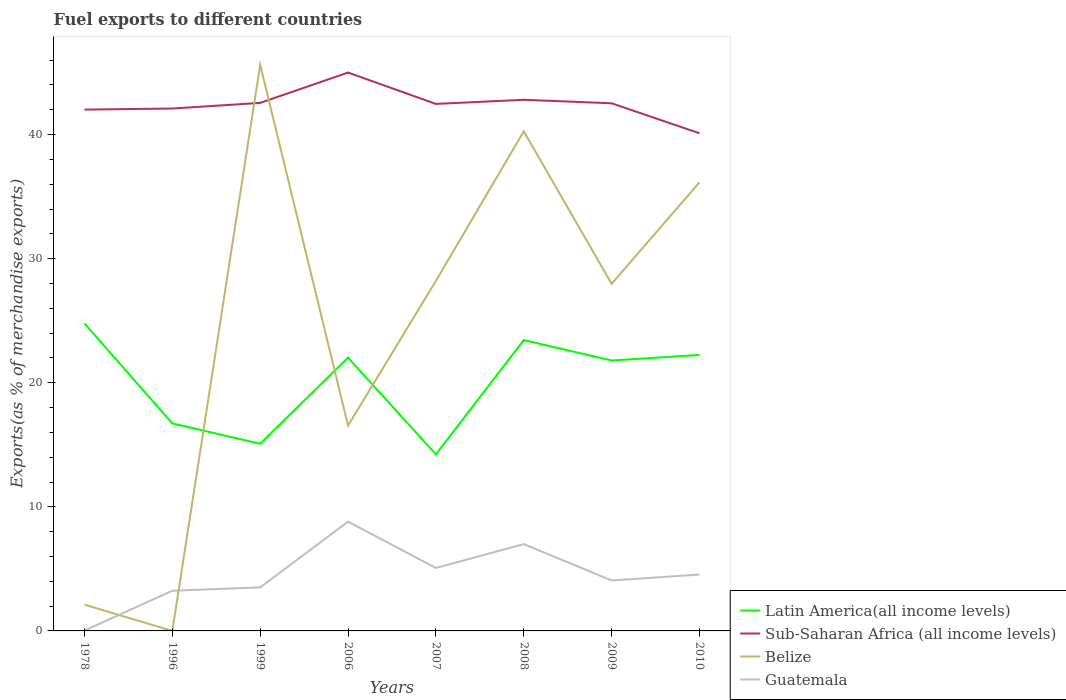Does the line corresponding to Latin America(all income levels) intersect with the line corresponding to Belize?
Your response must be concise. Yes. Is the number of lines equal to the number of legend labels?
Make the answer very short. Yes. Across all years, what is the maximum percentage of exports to different countries in Guatemala?
Your response must be concise. 0.03. What is the total percentage of exports to different countries in Latin America(all income levels) in the graph?
Keep it short and to the point. 9.69. What is the difference between the highest and the second highest percentage of exports to different countries in Belize?
Give a very brief answer. 45.62. What is the difference between the highest and the lowest percentage of exports to different countries in Latin America(all income levels)?
Offer a very short reply. 5. How many lines are there?
Give a very brief answer. 4. How many years are there in the graph?
Your response must be concise. 8. What is the difference between two consecutive major ticks on the Y-axis?
Provide a succinct answer. 10. Are the values on the major ticks of Y-axis written in scientific E-notation?
Your answer should be very brief. No. Does the graph contain grids?
Give a very brief answer. No. What is the title of the graph?
Provide a short and direct response. Fuel exports to different countries. Does "Other small states" appear as one of the legend labels in the graph?
Offer a very short reply. No. What is the label or title of the X-axis?
Your response must be concise. Years. What is the label or title of the Y-axis?
Your answer should be compact. Exports(as % of merchandise exports). What is the Exports(as % of merchandise exports) in Latin America(all income levels) in 1978?
Make the answer very short. 24.78. What is the Exports(as % of merchandise exports) of Sub-Saharan Africa (all income levels) in 1978?
Keep it short and to the point. 42.01. What is the Exports(as % of merchandise exports) in Belize in 1978?
Keep it short and to the point. 2.12. What is the Exports(as % of merchandise exports) of Guatemala in 1978?
Give a very brief answer. 0.03. What is the Exports(as % of merchandise exports) of Latin America(all income levels) in 1996?
Keep it short and to the point. 16.72. What is the Exports(as % of merchandise exports) of Sub-Saharan Africa (all income levels) in 1996?
Offer a terse response. 42.1. What is the Exports(as % of merchandise exports) of Belize in 1996?
Offer a terse response. 0. What is the Exports(as % of merchandise exports) in Guatemala in 1996?
Offer a terse response. 3.24. What is the Exports(as % of merchandise exports) of Latin America(all income levels) in 1999?
Give a very brief answer. 15.09. What is the Exports(as % of merchandise exports) of Sub-Saharan Africa (all income levels) in 1999?
Give a very brief answer. 42.55. What is the Exports(as % of merchandise exports) of Belize in 1999?
Make the answer very short. 45.62. What is the Exports(as % of merchandise exports) of Guatemala in 1999?
Keep it short and to the point. 3.51. What is the Exports(as % of merchandise exports) in Latin America(all income levels) in 2006?
Your response must be concise. 22.02. What is the Exports(as % of merchandise exports) in Sub-Saharan Africa (all income levels) in 2006?
Offer a terse response. 45. What is the Exports(as % of merchandise exports) in Belize in 2006?
Provide a succinct answer. 16.55. What is the Exports(as % of merchandise exports) of Guatemala in 2006?
Offer a terse response. 8.81. What is the Exports(as % of merchandise exports) in Latin America(all income levels) in 2007?
Your answer should be compact. 14.23. What is the Exports(as % of merchandise exports) of Sub-Saharan Africa (all income levels) in 2007?
Offer a terse response. 42.47. What is the Exports(as % of merchandise exports) in Belize in 2007?
Your response must be concise. 28.21. What is the Exports(as % of merchandise exports) in Guatemala in 2007?
Provide a short and direct response. 5.07. What is the Exports(as % of merchandise exports) of Latin America(all income levels) in 2008?
Provide a succinct answer. 23.44. What is the Exports(as % of merchandise exports) of Sub-Saharan Africa (all income levels) in 2008?
Make the answer very short. 42.8. What is the Exports(as % of merchandise exports) in Belize in 2008?
Your response must be concise. 40.26. What is the Exports(as % of merchandise exports) of Guatemala in 2008?
Offer a very short reply. 7. What is the Exports(as % of merchandise exports) of Latin America(all income levels) in 2009?
Ensure brevity in your answer.  21.79. What is the Exports(as % of merchandise exports) of Sub-Saharan Africa (all income levels) in 2009?
Provide a succinct answer. 42.52. What is the Exports(as % of merchandise exports) of Belize in 2009?
Your answer should be compact. 27.97. What is the Exports(as % of merchandise exports) in Guatemala in 2009?
Your response must be concise. 4.07. What is the Exports(as % of merchandise exports) of Latin America(all income levels) in 2010?
Keep it short and to the point. 22.24. What is the Exports(as % of merchandise exports) of Sub-Saharan Africa (all income levels) in 2010?
Provide a succinct answer. 40.1. What is the Exports(as % of merchandise exports) in Belize in 2010?
Make the answer very short. 36.15. What is the Exports(as % of merchandise exports) of Guatemala in 2010?
Provide a succinct answer. 4.54. Across all years, what is the maximum Exports(as % of merchandise exports) of Latin America(all income levels)?
Make the answer very short. 24.78. Across all years, what is the maximum Exports(as % of merchandise exports) in Sub-Saharan Africa (all income levels)?
Keep it short and to the point. 45. Across all years, what is the maximum Exports(as % of merchandise exports) in Belize?
Provide a short and direct response. 45.62. Across all years, what is the maximum Exports(as % of merchandise exports) of Guatemala?
Your response must be concise. 8.81. Across all years, what is the minimum Exports(as % of merchandise exports) in Latin America(all income levels)?
Provide a short and direct response. 14.23. Across all years, what is the minimum Exports(as % of merchandise exports) of Sub-Saharan Africa (all income levels)?
Keep it short and to the point. 40.1. Across all years, what is the minimum Exports(as % of merchandise exports) of Belize?
Provide a short and direct response. 0. Across all years, what is the minimum Exports(as % of merchandise exports) of Guatemala?
Make the answer very short. 0.03. What is the total Exports(as % of merchandise exports) in Latin America(all income levels) in the graph?
Make the answer very short. 160.31. What is the total Exports(as % of merchandise exports) of Sub-Saharan Africa (all income levels) in the graph?
Give a very brief answer. 339.56. What is the total Exports(as % of merchandise exports) in Belize in the graph?
Your response must be concise. 196.88. What is the total Exports(as % of merchandise exports) in Guatemala in the graph?
Your answer should be compact. 36.26. What is the difference between the Exports(as % of merchandise exports) of Latin America(all income levels) in 1978 and that in 1996?
Ensure brevity in your answer.  8.06. What is the difference between the Exports(as % of merchandise exports) of Sub-Saharan Africa (all income levels) in 1978 and that in 1996?
Ensure brevity in your answer.  -0.09. What is the difference between the Exports(as % of merchandise exports) in Belize in 1978 and that in 1996?
Keep it short and to the point. 2.12. What is the difference between the Exports(as % of merchandise exports) of Guatemala in 1978 and that in 1996?
Offer a very short reply. -3.21. What is the difference between the Exports(as % of merchandise exports) in Latin America(all income levels) in 1978 and that in 1999?
Your response must be concise. 9.69. What is the difference between the Exports(as % of merchandise exports) of Sub-Saharan Africa (all income levels) in 1978 and that in 1999?
Your answer should be very brief. -0.54. What is the difference between the Exports(as % of merchandise exports) in Belize in 1978 and that in 1999?
Keep it short and to the point. -43.5. What is the difference between the Exports(as % of merchandise exports) of Guatemala in 1978 and that in 1999?
Provide a succinct answer. -3.48. What is the difference between the Exports(as % of merchandise exports) in Latin America(all income levels) in 1978 and that in 2006?
Offer a very short reply. 2.76. What is the difference between the Exports(as % of merchandise exports) in Sub-Saharan Africa (all income levels) in 1978 and that in 2006?
Provide a short and direct response. -2.99. What is the difference between the Exports(as % of merchandise exports) of Belize in 1978 and that in 2006?
Your answer should be compact. -14.43. What is the difference between the Exports(as % of merchandise exports) in Guatemala in 1978 and that in 2006?
Offer a very short reply. -8.78. What is the difference between the Exports(as % of merchandise exports) in Latin America(all income levels) in 1978 and that in 2007?
Offer a very short reply. 10.55. What is the difference between the Exports(as % of merchandise exports) of Sub-Saharan Africa (all income levels) in 1978 and that in 2007?
Keep it short and to the point. -0.46. What is the difference between the Exports(as % of merchandise exports) in Belize in 1978 and that in 2007?
Give a very brief answer. -26.09. What is the difference between the Exports(as % of merchandise exports) of Guatemala in 1978 and that in 2007?
Offer a very short reply. -5.04. What is the difference between the Exports(as % of merchandise exports) of Latin America(all income levels) in 1978 and that in 2008?
Provide a succinct answer. 1.34. What is the difference between the Exports(as % of merchandise exports) in Sub-Saharan Africa (all income levels) in 1978 and that in 2008?
Give a very brief answer. -0.79. What is the difference between the Exports(as % of merchandise exports) in Belize in 1978 and that in 2008?
Keep it short and to the point. -38.15. What is the difference between the Exports(as % of merchandise exports) in Guatemala in 1978 and that in 2008?
Ensure brevity in your answer.  -6.97. What is the difference between the Exports(as % of merchandise exports) of Latin America(all income levels) in 1978 and that in 2009?
Provide a short and direct response. 2.99. What is the difference between the Exports(as % of merchandise exports) in Sub-Saharan Africa (all income levels) in 1978 and that in 2009?
Make the answer very short. -0.51. What is the difference between the Exports(as % of merchandise exports) in Belize in 1978 and that in 2009?
Make the answer very short. -25.86. What is the difference between the Exports(as % of merchandise exports) in Guatemala in 1978 and that in 2009?
Keep it short and to the point. -4.04. What is the difference between the Exports(as % of merchandise exports) in Latin America(all income levels) in 1978 and that in 2010?
Provide a short and direct response. 2.54. What is the difference between the Exports(as % of merchandise exports) of Sub-Saharan Africa (all income levels) in 1978 and that in 2010?
Ensure brevity in your answer.  1.91. What is the difference between the Exports(as % of merchandise exports) in Belize in 1978 and that in 2010?
Offer a terse response. -34.04. What is the difference between the Exports(as % of merchandise exports) of Guatemala in 1978 and that in 2010?
Your answer should be very brief. -4.51. What is the difference between the Exports(as % of merchandise exports) in Latin America(all income levels) in 1996 and that in 1999?
Your answer should be compact. 1.64. What is the difference between the Exports(as % of merchandise exports) in Sub-Saharan Africa (all income levels) in 1996 and that in 1999?
Provide a short and direct response. -0.45. What is the difference between the Exports(as % of merchandise exports) in Belize in 1996 and that in 1999?
Provide a short and direct response. -45.62. What is the difference between the Exports(as % of merchandise exports) of Guatemala in 1996 and that in 1999?
Offer a terse response. -0.27. What is the difference between the Exports(as % of merchandise exports) in Latin America(all income levels) in 1996 and that in 2006?
Offer a very short reply. -5.3. What is the difference between the Exports(as % of merchandise exports) in Sub-Saharan Africa (all income levels) in 1996 and that in 2006?
Offer a very short reply. -2.9. What is the difference between the Exports(as % of merchandise exports) in Belize in 1996 and that in 2006?
Offer a very short reply. -16.55. What is the difference between the Exports(as % of merchandise exports) in Guatemala in 1996 and that in 2006?
Give a very brief answer. -5.57. What is the difference between the Exports(as % of merchandise exports) of Latin America(all income levels) in 1996 and that in 2007?
Offer a terse response. 2.49. What is the difference between the Exports(as % of merchandise exports) of Sub-Saharan Africa (all income levels) in 1996 and that in 2007?
Provide a short and direct response. -0.37. What is the difference between the Exports(as % of merchandise exports) of Belize in 1996 and that in 2007?
Keep it short and to the point. -28.21. What is the difference between the Exports(as % of merchandise exports) of Guatemala in 1996 and that in 2007?
Offer a very short reply. -1.83. What is the difference between the Exports(as % of merchandise exports) of Latin America(all income levels) in 1996 and that in 2008?
Offer a very short reply. -6.71. What is the difference between the Exports(as % of merchandise exports) of Sub-Saharan Africa (all income levels) in 1996 and that in 2008?
Give a very brief answer. -0.7. What is the difference between the Exports(as % of merchandise exports) in Belize in 1996 and that in 2008?
Give a very brief answer. -40.26. What is the difference between the Exports(as % of merchandise exports) of Guatemala in 1996 and that in 2008?
Make the answer very short. -3.76. What is the difference between the Exports(as % of merchandise exports) of Latin America(all income levels) in 1996 and that in 2009?
Keep it short and to the point. -5.07. What is the difference between the Exports(as % of merchandise exports) of Sub-Saharan Africa (all income levels) in 1996 and that in 2009?
Give a very brief answer. -0.42. What is the difference between the Exports(as % of merchandise exports) in Belize in 1996 and that in 2009?
Offer a very short reply. -27.97. What is the difference between the Exports(as % of merchandise exports) of Guatemala in 1996 and that in 2009?
Ensure brevity in your answer.  -0.83. What is the difference between the Exports(as % of merchandise exports) in Latin America(all income levels) in 1996 and that in 2010?
Keep it short and to the point. -5.52. What is the difference between the Exports(as % of merchandise exports) of Sub-Saharan Africa (all income levels) in 1996 and that in 2010?
Provide a short and direct response. 2. What is the difference between the Exports(as % of merchandise exports) in Belize in 1996 and that in 2010?
Offer a terse response. -36.15. What is the difference between the Exports(as % of merchandise exports) in Guatemala in 1996 and that in 2010?
Provide a succinct answer. -1.31. What is the difference between the Exports(as % of merchandise exports) in Latin America(all income levels) in 1999 and that in 2006?
Your answer should be very brief. -6.93. What is the difference between the Exports(as % of merchandise exports) in Sub-Saharan Africa (all income levels) in 1999 and that in 2006?
Offer a very short reply. -2.45. What is the difference between the Exports(as % of merchandise exports) of Belize in 1999 and that in 2006?
Make the answer very short. 29.07. What is the difference between the Exports(as % of merchandise exports) of Guatemala in 1999 and that in 2006?
Your answer should be compact. -5.3. What is the difference between the Exports(as % of merchandise exports) of Latin America(all income levels) in 1999 and that in 2007?
Give a very brief answer. 0.86. What is the difference between the Exports(as % of merchandise exports) of Sub-Saharan Africa (all income levels) in 1999 and that in 2007?
Give a very brief answer. 0.08. What is the difference between the Exports(as % of merchandise exports) in Belize in 1999 and that in 2007?
Keep it short and to the point. 17.41. What is the difference between the Exports(as % of merchandise exports) in Guatemala in 1999 and that in 2007?
Provide a short and direct response. -1.57. What is the difference between the Exports(as % of merchandise exports) in Latin America(all income levels) in 1999 and that in 2008?
Your response must be concise. -8.35. What is the difference between the Exports(as % of merchandise exports) in Sub-Saharan Africa (all income levels) in 1999 and that in 2008?
Your answer should be very brief. -0.25. What is the difference between the Exports(as % of merchandise exports) of Belize in 1999 and that in 2008?
Keep it short and to the point. 5.35. What is the difference between the Exports(as % of merchandise exports) of Guatemala in 1999 and that in 2008?
Your answer should be compact. -3.49. What is the difference between the Exports(as % of merchandise exports) of Latin America(all income levels) in 1999 and that in 2009?
Keep it short and to the point. -6.71. What is the difference between the Exports(as % of merchandise exports) of Sub-Saharan Africa (all income levels) in 1999 and that in 2009?
Provide a short and direct response. 0.03. What is the difference between the Exports(as % of merchandise exports) in Belize in 1999 and that in 2009?
Ensure brevity in your answer.  17.64. What is the difference between the Exports(as % of merchandise exports) in Guatemala in 1999 and that in 2009?
Give a very brief answer. -0.56. What is the difference between the Exports(as % of merchandise exports) in Latin America(all income levels) in 1999 and that in 2010?
Keep it short and to the point. -7.16. What is the difference between the Exports(as % of merchandise exports) in Sub-Saharan Africa (all income levels) in 1999 and that in 2010?
Make the answer very short. 2.45. What is the difference between the Exports(as % of merchandise exports) of Belize in 1999 and that in 2010?
Provide a succinct answer. 9.46. What is the difference between the Exports(as % of merchandise exports) in Guatemala in 1999 and that in 2010?
Offer a very short reply. -1.04. What is the difference between the Exports(as % of merchandise exports) of Latin America(all income levels) in 2006 and that in 2007?
Make the answer very short. 7.79. What is the difference between the Exports(as % of merchandise exports) of Sub-Saharan Africa (all income levels) in 2006 and that in 2007?
Give a very brief answer. 2.53. What is the difference between the Exports(as % of merchandise exports) of Belize in 2006 and that in 2007?
Provide a succinct answer. -11.66. What is the difference between the Exports(as % of merchandise exports) of Guatemala in 2006 and that in 2007?
Offer a very short reply. 3.73. What is the difference between the Exports(as % of merchandise exports) of Latin America(all income levels) in 2006 and that in 2008?
Your answer should be compact. -1.42. What is the difference between the Exports(as % of merchandise exports) in Sub-Saharan Africa (all income levels) in 2006 and that in 2008?
Offer a very short reply. 2.19. What is the difference between the Exports(as % of merchandise exports) of Belize in 2006 and that in 2008?
Your response must be concise. -23.71. What is the difference between the Exports(as % of merchandise exports) in Guatemala in 2006 and that in 2008?
Provide a short and direct response. 1.81. What is the difference between the Exports(as % of merchandise exports) of Latin America(all income levels) in 2006 and that in 2009?
Provide a succinct answer. 0.23. What is the difference between the Exports(as % of merchandise exports) in Sub-Saharan Africa (all income levels) in 2006 and that in 2009?
Provide a short and direct response. 2.48. What is the difference between the Exports(as % of merchandise exports) of Belize in 2006 and that in 2009?
Your answer should be very brief. -11.42. What is the difference between the Exports(as % of merchandise exports) of Guatemala in 2006 and that in 2009?
Keep it short and to the point. 4.74. What is the difference between the Exports(as % of merchandise exports) in Latin America(all income levels) in 2006 and that in 2010?
Your answer should be very brief. -0.22. What is the difference between the Exports(as % of merchandise exports) of Sub-Saharan Africa (all income levels) in 2006 and that in 2010?
Provide a succinct answer. 4.89. What is the difference between the Exports(as % of merchandise exports) of Belize in 2006 and that in 2010?
Offer a very short reply. -19.6. What is the difference between the Exports(as % of merchandise exports) of Guatemala in 2006 and that in 2010?
Your response must be concise. 4.26. What is the difference between the Exports(as % of merchandise exports) of Latin America(all income levels) in 2007 and that in 2008?
Offer a terse response. -9.21. What is the difference between the Exports(as % of merchandise exports) of Sub-Saharan Africa (all income levels) in 2007 and that in 2008?
Offer a terse response. -0.33. What is the difference between the Exports(as % of merchandise exports) in Belize in 2007 and that in 2008?
Your answer should be compact. -12.05. What is the difference between the Exports(as % of merchandise exports) in Guatemala in 2007 and that in 2008?
Give a very brief answer. -1.92. What is the difference between the Exports(as % of merchandise exports) in Latin America(all income levels) in 2007 and that in 2009?
Provide a short and direct response. -7.56. What is the difference between the Exports(as % of merchandise exports) in Sub-Saharan Africa (all income levels) in 2007 and that in 2009?
Your answer should be compact. -0.05. What is the difference between the Exports(as % of merchandise exports) of Belize in 2007 and that in 2009?
Give a very brief answer. 0.24. What is the difference between the Exports(as % of merchandise exports) of Guatemala in 2007 and that in 2009?
Your answer should be very brief. 1.01. What is the difference between the Exports(as % of merchandise exports) in Latin America(all income levels) in 2007 and that in 2010?
Offer a terse response. -8.01. What is the difference between the Exports(as % of merchandise exports) in Sub-Saharan Africa (all income levels) in 2007 and that in 2010?
Keep it short and to the point. 2.37. What is the difference between the Exports(as % of merchandise exports) of Belize in 2007 and that in 2010?
Provide a short and direct response. -7.94. What is the difference between the Exports(as % of merchandise exports) of Guatemala in 2007 and that in 2010?
Offer a very short reply. 0.53. What is the difference between the Exports(as % of merchandise exports) in Latin America(all income levels) in 2008 and that in 2009?
Offer a very short reply. 1.65. What is the difference between the Exports(as % of merchandise exports) of Sub-Saharan Africa (all income levels) in 2008 and that in 2009?
Your answer should be very brief. 0.28. What is the difference between the Exports(as % of merchandise exports) in Belize in 2008 and that in 2009?
Offer a very short reply. 12.29. What is the difference between the Exports(as % of merchandise exports) of Guatemala in 2008 and that in 2009?
Give a very brief answer. 2.93. What is the difference between the Exports(as % of merchandise exports) of Latin America(all income levels) in 2008 and that in 2010?
Give a very brief answer. 1.2. What is the difference between the Exports(as % of merchandise exports) in Sub-Saharan Africa (all income levels) in 2008 and that in 2010?
Give a very brief answer. 2.7. What is the difference between the Exports(as % of merchandise exports) of Belize in 2008 and that in 2010?
Keep it short and to the point. 4.11. What is the difference between the Exports(as % of merchandise exports) of Guatemala in 2008 and that in 2010?
Make the answer very short. 2.45. What is the difference between the Exports(as % of merchandise exports) of Latin America(all income levels) in 2009 and that in 2010?
Make the answer very short. -0.45. What is the difference between the Exports(as % of merchandise exports) of Sub-Saharan Africa (all income levels) in 2009 and that in 2010?
Provide a short and direct response. 2.42. What is the difference between the Exports(as % of merchandise exports) in Belize in 2009 and that in 2010?
Provide a short and direct response. -8.18. What is the difference between the Exports(as % of merchandise exports) of Guatemala in 2009 and that in 2010?
Your response must be concise. -0.48. What is the difference between the Exports(as % of merchandise exports) of Latin America(all income levels) in 1978 and the Exports(as % of merchandise exports) of Sub-Saharan Africa (all income levels) in 1996?
Your response must be concise. -17.32. What is the difference between the Exports(as % of merchandise exports) in Latin America(all income levels) in 1978 and the Exports(as % of merchandise exports) in Belize in 1996?
Offer a very short reply. 24.78. What is the difference between the Exports(as % of merchandise exports) of Latin America(all income levels) in 1978 and the Exports(as % of merchandise exports) of Guatemala in 1996?
Your response must be concise. 21.54. What is the difference between the Exports(as % of merchandise exports) of Sub-Saharan Africa (all income levels) in 1978 and the Exports(as % of merchandise exports) of Belize in 1996?
Offer a very short reply. 42.01. What is the difference between the Exports(as % of merchandise exports) in Sub-Saharan Africa (all income levels) in 1978 and the Exports(as % of merchandise exports) in Guatemala in 1996?
Ensure brevity in your answer.  38.77. What is the difference between the Exports(as % of merchandise exports) of Belize in 1978 and the Exports(as % of merchandise exports) of Guatemala in 1996?
Keep it short and to the point. -1.12. What is the difference between the Exports(as % of merchandise exports) in Latin America(all income levels) in 1978 and the Exports(as % of merchandise exports) in Sub-Saharan Africa (all income levels) in 1999?
Make the answer very short. -17.77. What is the difference between the Exports(as % of merchandise exports) in Latin America(all income levels) in 1978 and the Exports(as % of merchandise exports) in Belize in 1999?
Your response must be concise. -20.84. What is the difference between the Exports(as % of merchandise exports) of Latin America(all income levels) in 1978 and the Exports(as % of merchandise exports) of Guatemala in 1999?
Ensure brevity in your answer.  21.27. What is the difference between the Exports(as % of merchandise exports) in Sub-Saharan Africa (all income levels) in 1978 and the Exports(as % of merchandise exports) in Belize in 1999?
Keep it short and to the point. -3.6. What is the difference between the Exports(as % of merchandise exports) in Sub-Saharan Africa (all income levels) in 1978 and the Exports(as % of merchandise exports) in Guatemala in 1999?
Ensure brevity in your answer.  38.51. What is the difference between the Exports(as % of merchandise exports) in Belize in 1978 and the Exports(as % of merchandise exports) in Guatemala in 1999?
Your response must be concise. -1.39. What is the difference between the Exports(as % of merchandise exports) of Latin America(all income levels) in 1978 and the Exports(as % of merchandise exports) of Sub-Saharan Africa (all income levels) in 2006?
Offer a very short reply. -20.22. What is the difference between the Exports(as % of merchandise exports) of Latin America(all income levels) in 1978 and the Exports(as % of merchandise exports) of Belize in 2006?
Offer a very short reply. 8.23. What is the difference between the Exports(as % of merchandise exports) of Latin America(all income levels) in 1978 and the Exports(as % of merchandise exports) of Guatemala in 2006?
Give a very brief answer. 15.97. What is the difference between the Exports(as % of merchandise exports) in Sub-Saharan Africa (all income levels) in 1978 and the Exports(as % of merchandise exports) in Belize in 2006?
Your answer should be very brief. 25.46. What is the difference between the Exports(as % of merchandise exports) in Sub-Saharan Africa (all income levels) in 1978 and the Exports(as % of merchandise exports) in Guatemala in 2006?
Offer a terse response. 33.21. What is the difference between the Exports(as % of merchandise exports) of Belize in 1978 and the Exports(as % of merchandise exports) of Guatemala in 2006?
Keep it short and to the point. -6.69. What is the difference between the Exports(as % of merchandise exports) of Latin America(all income levels) in 1978 and the Exports(as % of merchandise exports) of Sub-Saharan Africa (all income levels) in 2007?
Your response must be concise. -17.69. What is the difference between the Exports(as % of merchandise exports) of Latin America(all income levels) in 1978 and the Exports(as % of merchandise exports) of Belize in 2007?
Your answer should be very brief. -3.43. What is the difference between the Exports(as % of merchandise exports) in Latin America(all income levels) in 1978 and the Exports(as % of merchandise exports) in Guatemala in 2007?
Your answer should be very brief. 19.71. What is the difference between the Exports(as % of merchandise exports) in Sub-Saharan Africa (all income levels) in 1978 and the Exports(as % of merchandise exports) in Belize in 2007?
Offer a terse response. 13.8. What is the difference between the Exports(as % of merchandise exports) of Sub-Saharan Africa (all income levels) in 1978 and the Exports(as % of merchandise exports) of Guatemala in 2007?
Provide a short and direct response. 36.94. What is the difference between the Exports(as % of merchandise exports) in Belize in 1978 and the Exports(as % of merchandise exports) in Guatemala in 2007?
Give a very brief answer. -2.96. What is the difference between the Exports(as % of merchandise exports) in Latin America(all income levels) in 1978 and the Exports(as % of merchandise exports) in Sub-Saharan Africa (all income levels) in 2008?
Make the answer very short. -18.02. What is the difference between the Exports(as % of merchandise exports) of Latin America(all income levels) in 1978 and the Exports(as % of merchandise exports) of Belize in 2008?
Offer a very short reply. -15.48. What is the difference between the Exports(as % of merchandise exports) of Latin America(all income levels) in 1978 and the Exports(as % of merchandise exports) of Guatemala in 2008?
Your response must be concise. 17.78. What is the difference between the Exports(as % of merchandise exports) of Sub-Saharan Africa (all income levels) in 1978 and the Exports(as % of merchandise exports) of Belize in 2008?
Make the answer very short. 1.75. What is the difference between the Exports(as % of merchandise exports) of Sub-Saharan Africa (all income levels) in 1978 and the Exports(as % of merchandise exports) of Guatemala in 2008?
Ensure brevity in your answer.  35.02. What is the difference between the Exports(as % of merchandise exports) of Belize in 1978 and the Exports(as % of merchandise exports) of Guatemala in 2008?
Provide a succinct answer. -4.88. What is the difference between the Exports(as % of merchandise exports) in Latin America(all income levels) in 1978 and the Exports(as % of merchandise exports) in Sub-Saharan Africa (all income levels) in 2009?
Provide a succinct answer. -17.74. What is the difference between the Exports(as % of merchandise exports) in Latin America(all income levels) in 1978 and the Exports(as % of merchandise exports) in Belize in 2009?
Offer a terse response. -3.19. What is the difference between the Exports(as % of merchandise exports) of Latin America(all income levels) in 1978 and the Exports(as % of merchandise exports) of Guatemala in 2009?
Your response must be concise. 20.71. What is the difference between the Exports(as % of merchandise exports) of Sub-Saharan Africa (all income levels) in 1978 and the Exports(as % of merchandise exports) of Belize in 2009?
Your answer should be very brief. 14.04. What is the difference between the Exports(as % of merchandise exports) of Sub-Saharan Africa (all income levels) in 1978 and the Exports(as % of merchandise exports) of Guatemala in 2009?
Provide a short and direct response. 37.95. What is the difference between the Exports(as % of merchandise exports) in Belize in 1978 and the Exports(as % of merchandise exports) in Guatemala in 2009?
Give a very brief answer. -1.95. What is the difference between the Exports(as % of merchandise exports) of Latin America(all income levels) in 1978 and the Exports(as % of merchandise exports) of Sub-Saharan Africa (all income levels) in 2010?
Your answer should be compact. -15.32. What is the difference between the Exports(as % of merchandise exports) in Latin America(all income levels) in 1978 and the Exports(as % of merchandise exports) in Belize in 2010?
Your answer should be very brief. -11.37. What is the difference between the Exports(as % of merchandise exports) in Latin America(all income levels) in 1978 and the Exports(as % of merchandise exports) in Guatemala in 2010?
Your response must be concise. 20.24. What is the difference between the Exports(as % of merchandise exports) in Sub-Saharan Africa (all income levels) in 1978 and the Exports(as % of merchandise exports) in Belize in 2010?
Make the answer very short. 5.86. What is the difference between the Exports(as % of merchandise exports) in Sub-Saharan Africa (all income levels) in 1978 and the Exports(as % of merchandise exports) in Guatemala in 2010?
Provide a short and direct response. 37.47. What is the difference between the Exports(as % of merchandise exports) of Belize in 1978 and the Exports(as % of merchandise exports) of Guatemala in 2010?
Ensure brevity in your answer.  -2.43. What is the difference between the Exports(as % of merchandise exports) of Latin America(all income levels) in 1996 and the Exports(as % of merchandise exports) of Sub-Saharan Africa (all income levels) in 1999?
Provide a succinct answer. -25.83. What is the difference between the Exports(as % of merchandise exports) in Latin America(all income levels) in 1996 and the Exports(as % of merchandise exports) in Belize in 1999?
Offer a terse response. -28.89. What is the difference between the Exports(as % of merchandise exports) in Latin America(all income levels) in 1996 and the Exports(as % of merchandise exports) in Guatemala in 1999?
Make the answer very short. 13.22. What is the difference between the Exports(as % of merchandise exports) in Sub-Saharan Africa (all income levels) in 1996 and the Exports(as % of merchandise exports) in Belize in 1999?
Provide a succinct answer. -3.52. What is the difference between the Exports(as % of merchandise exports) in Sub-Saharan Africa (all income levels) in 1996 and the Exports(as % of merchandise exports) in Guatemala in 1999?
Ensure brevity in your answer.  38.59. What is the difference between the Exports(as % of merchandise exports) of Belize in 1996 and the Exports(as % of merchandise exports) of Guatemala in 1999?
Ensure brevity in your answer.  -3.51. What is the difference between the Exports(as % of merchandise exports) in Latin America(all income levels) in 1996 and the Exports(as % of merchandise exports) in Sub-Saharan Africa (all income levels) in 2006?
Offer a very short reply. -28.27. What is the difference between the Exports(as % of merchandise exports) in Latin America(all income levels) in 1996 and the Exports(as % of merchandise exports) in Belize in 2006?
Give a very brief answer. 0.18. What is the difference between the Exports(as % of merchandise exports) of Latin America(all income levels) in 1996 and the Exports(as % of merchandise exports) of Guatemala in 2006?
Keep it short and to the point. 7.92. What is the difference between the Exports(as % of merchandise exports) of Sub-Saharan Africa (all income levels) in 1996 and the Exports(as % of merchandise exports) of Belize in 2006?
Your answer should be very brief. 25.55. What is the difference between the Exports(as % of merchandise exports) in Sub-Saharan Africa (all income levels) in 1996 and the Exports(as % of merchandise exports) in Guatemala in 2006?
Give a very brief answer. 33.29. What is the difference between the Exports(as % of merchandise exports) of Belize in 1996 and the Exports(as % of merchandise exports) of Guatemala in 2006?
Your response must be concise. -8.81. What is the difference between the Exports(as % of merchandise exports) of Latin America(all income levels) in 1996 and the Exports(as % of merchandise exports) of Sub-Saharan Africa (all income levels) in 2007?
Ensure brevity in your answer.  -25.75. What is the difference between the Exports(as % of merchandise exports) in Latin America(all income levels) in 1996 and the Exports(as % of merchandise exports) in Belize in 2007?
Make the answer very short. -11.48. What is the difference between the Exports(as % of merchandise exports) of Latin America(all income levels) in 1996 and the Exports(as % of merchandise exports) of Guatemala in 2007?
Ensure brevity in your answer.  11.65. What is the difference between the Exports(as % of merchandise exports) of Sub-Saharan Africa (all income levels) in 1996 and the Exports(as % of merchandise exports) of Belize in 2007?
Provide a short and direct response. 13.89. What is the difference between the Exports(as % of merchandise exports) of Sub-Saharan Africa (all income levels) in 1996 and the Exports(as % of merchandise exports) of Guatemala in 2007?
Keep it short and to the point. 37.03. What is the difference between the Exports(as % of merchandise exports) in Belize in 1996 and the Exports(as % of merchandise exports) in Guatemala in 2007?
Your answer should be very brief. -5.07. What is the difference between the Exports(as % of merchandise exports) of Latin America(all income levels) in 1996 and the Exports(as % of merchandise exports) of Sub-Saharan Africa (all income levels) in 2008?
Your answer should be very brief. -26.08. What is the difference between the Exports(as % of merchandise exports) of Latin America(all income levels) in 1996 and the Exports(as % of merchandise exports) of Belize in 2008?
Make the answer very short. -23.54. What is the difference between the Exports(as % of merchandise exports) of Latin America(all income levels) in 1996 and the Exports(as % of merchandise exports) of Guatemala in 2008?
Provide a short and direct response. 9.73. What is the difference between the Exports(as % of merchandise exports) in Sub-Saharan Africa (all income levels) in 1996 and the Exports(as % of merchandise exports) in Belize in 2008?
Your response must be concise. 1.84. What is the difference between the Exports(as % of merchandise exports) of Sub-Saharan Africa (all income levels) in 1996 and the Exports(as % of merchandise exports) of Guatemala in 2008?
Give a very brief answer. 35.1. What is the difference between the Exports(as % of merchandise exports) of Belize in 1996 and the Exports(as % of merchandise exports) of Guatemala in 2008?
Make the answer very short. -7. What is the difference between the Exports(as % of merchandise exports) of Latin America(all income levels) in 1996 and the Exports(as % of merchandise exports) of Sub-Saharan Africa (all income levels) in 2009?
Your answer should be very brief. -25.8. What is the difference between the Exports(as % of merchandise exports) in Latin America(all income levels) in 1996 and the Exports(as % of merchandise exports) in Belize in 2009?
Give a very brief answer. -11.25. What is the difference between the Exports(as % of merchandise exports) of Latin America(all income levels) in 1996 and the Exports(as % of merchandise exports) of Guatemala in 2009?
Offer a very short reply. 12.66. What is the difference between the Exports(as % of merchandise exports) in Sub-Saharan Africa (all income levels) in 1996 and the Exports(as % of merchandise exports) in Belize in 2009?
Provide a short and direct response. 14.13. What is the difference between the Exports(as % of merchandise exports) in Sub-Saharan Africa (all income levels) in 1996 and the Exports(as % of merchandise exports) in Guatemala in 2009?
Provide a short and direct response. 38.03. What is the difference between the Exports(as % of merchandise exports) of Belize in 1996 and the Exports(as % of merchandise exports) of Guatemala in 2009?
Your answer should be compact. -4.07. What is the difference between the Exports(as % of merchandise exports) of Latin America(all income levels) in 1996 and the Exports(as % of merchandise exports) of Sub-Saharan Africa (all income levels) in 2010?
Provide a succinct answer. -23.38. What is the difference between the Exports(as % of merchandise exports) of Latin America(all income levels) in 1996 and the Exports(as % of merchandise exports) of Belize in 2010?
Ensure brevity in your answer.  -19.43. What is the difference between the Exports(as % of merchandise exports) in Latin America(all income levels) in 1996 and the Exports(as % of merchandise exports) in Guatemala in 2010?
Provide a succinct answer. 12.18. What is the difference between the Exports(as % of merchandise exports) in Sub-Saharan Africa (all income levels) in 1996 and the Exports(as % of merchandise exports) in Belize in 2010?
Your answer should be compact. 5.95. What is the difference between the Exports(as % of merchandise exports) of Sub-Saharan Africa (all income levels) in 1996 and the Exports(as % of merchandise exports) of Guatemala in 2010?
Provide a short and direct response. 37.56. What is the difference between the Exports(as % of merchandise exports) of Belize in 1996 and the Exports(as % of merchandise exports) of Guatemala in 2010?
Keep it short and to the point. -4.54. What is the difference between the Exports(as % of merchandise exports) in Latin America(all income levels) in 1999 and the Exports(as % of merchandise exports) in Sub-Saharan Africa (all income levels) in 2006?
Your answer should be very brief. -29.91. What is the difference between the Exports(as % of merchandise exports) in Latin America(all income levels) in 1999 and the Exports(as % of merchandise exports) in Belize in 2006?
Your response must be concise. -1.46. What is the difference between the Exports(as % of merchandise exports) of Latin America(all income levels) in 1999 and the Exports(as % of merchandise exports) of Guatemala in 2006?
Provide a succinct answer. 6.28. What is the difference between the Exports(as % of merchandise exports) in Sub-Saharan Africa (all income levels) in 1999 and the Exports(as % of merchandise exports) in Belize in 2006?
Give a very brief answer. 26. What is the difference between the Exports(as % of merchandise exports) of Sub-Saharan Africa (all income levels) in 1999 and the Exports(as % of merchandise exports) of Guatemala in 2006?
Keep it short and to the point. 33.75. What is the difference between the Exports(as % of merchandise exports) in Belize in 1999 and the Exports(as % of merchandise exports) in Guatemala in 2006?
Offer a very short reply. 36.81. What is the difference between the Exports(as % of merchandise exports) in Latin America(all income levels) in 1999 and the Exports(as % of merchandise exports) in Sub-Saharan Africa (all income levels) in 2007?
Your answer should be very brief. -27.38. What is the difference between the Exports(as % of merchandise exports) of Latin America(all income levels) in 1999 and the Exports(as % of merchandise exports) of Belize in 2007?
Give a very brief answer. -13.12. What is the difference between the Exports(as % of merchandise exports) in Latin America(all income levels) in 1999 and the Exports(as % of merchandise exports) in Guatemala in 2007?
Provide a short and direct response. 10.01. What is the difference between the Exports(as % of merchandise exports) in Sub-Saharan Africa (all income levels) in 1999 and the Exports(as % of merchandise exports) in Belize in 2007?
Offer a terse response. 14.34. What is the difference between the Exports(as % of merchandise exports) of Sub-Saharan Africa (all income levels) in 1999 and the Exports(as % of merchandise exports) of Guatemala in 2007?
Offer a very short reply. 37.48. What is the difference between the Exports(as % of merchandise exports) of Belize in 1999 and the Exports(as % of merchandise exports) of Guatemala in 2007?
Your answer should be very brief. 40.54. What is the difference between the Exports(as % of merchandise exports) in Latin America(all income levels) in 1999 and the Exports(as % of merchandise exports) in Sub-Saharan Africa (all income levels) in 2008?
Your response must be concise. -27.72. What is the difference between the Exports(as % of merchandise exports) of Latin America(all income levels) in 1999 and the Exports(as % of merchandise exports) of Belize in 2008?
Keep it short and to the point. -25.18. What is the difference between the Exports(as % of merchandise exports) in Latin America(all income levels) in 1999 and the Exports(as % of merchandise exports) in Guatemala in 2008?
Offer a terse response. 8.09. What is the difference between the Exports(as % of merchandise exports) in Sub-Saharan Africa (all income levels) in 1999 and the Exports(as % of merchandise exports) in Belize in 2008?
Your answer should be very brief. 2.29. What is the difference between the Exports(as % of merchandise exports) of Sub-Saharan Africa (all income levels) in 1999 and the Exports(as % of merchandise exports) of Guatemala in 2008?
Ensure brevity in your answer.  35.56. What is the difference between the Exports(as % of merchandise exports) in Belize in 1999 and the Exports(as % of merchandise exports) in Guatemala in 2008?
Make the answer very short. 38.62. What is the difference between the Exports(as % of merchandise exports) of Latin America(all income levels) in 1999 and the Exports(as % of merchandise exports) of Sub-Saharan Africa (all income levels) in 2009?
Provide a short and direct response. -27.44. What is the difference between the Exports(as % of merchandise exports) in Latin America(all income levels) in 1999 and the Exports(as % of merchandise exports) in Belize in 2009?
Ensure brevity in your answer.  -12.89. What is the difference between the Exports(as % of merchandise exports) of Latin America(all income levels) in 1999 and the Exports(as % of merchandise exports) of Guatemala in 2009?
Offer a very short reply. 11.02. What is the difference between the Exports(as % of merchandise exports) in Sub-Saharan Africa (all income levels) in 1999 and the Exports(as % of merchandise exports) in Belize in 2009?
Make the answer very short. 14.58. What is the difference between the Exports(as % of merchandise exports) in Sub-Saharan Africa (all income levels) in 1999 and the Exports(as % of merchandise exports) in Guatemala in 2009?
Your answer should be very brief. 38.49. What is the difference between the Exports(as % of merchandise exports) in Belize in 1999 and the Exports(as % of merchandise exports) in Guatemala in 2009?
Offer a terse response. 41.55. What is the difference between the Exports(as % of merchandise exports) in Latin America(all income levels) in 1999 and the Exports(as % of merchandise exports) in Sub-Saharan Africa (all income levels) in 2010?
Offer a terse response. -25.02. What is the difference between the Exports(as % of merchandise exports) in Latin America(all income levels) in 1999 and the Exports(as % of merchandise exports) in Belize in 2010?
Your answer should be compact. -21.07. What is the difference between the Exports(as % of merchandise exports) of Latin America(all income levels) in 1999 and the Exports(as % of merchandise exports) of Guatemala in 2010?
Offer a very short reply. 10.54. What is the difference between the Exports(as % of merchandise exports) of Sub-Saharan Africa (all income levels) in 1999 and the Exports(as % of merchandise exports) of Belize in 2010?
Offer a very short reply. 6.4. What is the difference between the Exports(as % of merchandise exports) of Sub-Saharan Africa (all income levels) in 1999 and the Exports(as % of merchandise exports) of Guatemala in 2010?
Your response must be concise. 38.01. What is the difference between the Exports(as % of merchandise exports) in Belize in 1999 and the Exports(as % of merchandise exports) in Guatemala in 2010?
Offer a very short reply. 41.07. What is the difference between the Exports(as % of merchandise exports) of Latin America(all income levels) in 2006 and the Exports(as % of merchandise exports) of Sub-Saharan Africa (all income levels) in 2007?
Offer a terse response. -20.45. What is the difference between the Exports(as % of merchandise exports) of Latin America(all income levels) in 2006 and the Exports(as % of merchandise exports) of Belize in 2007?
Your answer should be compact. -6.19. What is the difference between the Exports(as % of merchandise exports) in Latin America(all income levels) in 2006 and the Exports(as % of merchandise exports) in Guatemala in 2007?
Your response must be concise. 16.95. What is the difference between the Exports(as % of merchandise exports) of Sub-Saharan Africa (all income levels) in 2006 and the Exports(as % of merchandise exports) of Belize in 2007?
Ensure brevity in your answer.  16.79. What is the difference between the Exports(as % of merchandise exports) in Sub-Saharan Africa (all income levels) in 2006 and the Exports(as % of merchandise exports) in Guatemala in 2007?
Provide a short and direct response. 39.93. What is the difference between the Exports(as % of merchandise exports) of Belize in 2006 and the Exports(as % of merchandise exports) of Guatemala in 2007?
Provide a succinct answer. 11.47. What is the difference between the Exports(as % of merchandise exports) of Latin America(all income levels) in 2006 and the Exports(as % of merchandise exports) of Sub-Saharan Africa (all income levels) in 2008?
Provide a succinct answer. -20.79. What is the difference between the Exports(as % of merchandise exports) in Latin America(all income levels) in 2006 and the Exports(as % of merchandise exports) in Belize in 2008?
Give a very brief answer. -18.24. What is the difference between the Exports(as % of merchandise exports) in Latin America(all income levels) in 2006 and the Exports(as % of merchandise exports) in Guatemala in 2008?
Provide a succinct answer. 15.02. What is the difference between the Exports(as % of merchandise exports) of Sub-Saharan Africa (all income levels) in 2006 and the Exports(as % of merchandise exports) of Belize in 2008?
Ensure brevity in your answer.  4.74. What is the difference between the Exports(as % of merchandise exports) in Sub-Saharan Africa (all income levels) in 2006 and the Exports(as % of merchandise exports) in Guatemala in 2008?
Offer a terse response. 38. What is the difference between the Exports(as % of merchandise exports) of Belize in 2006 and the Exports(as % of merchandise exports) of Guatemala in 2008?
Your answer should be compact. 9.55. What is the difference between the Exports(as % of merchandise exports) of Latin America(all income levels) in 2006 and the Exports(as % of merchandise exports) of Sub-Saharan Africa (all income levels) in 2009?
Provide a succinct answer. -20.5. What is the difference between the Exports(as % of merchandise exports) in Latin America(all income levels) in 2006 and the Exports(as % of merchandise exports) in Belize in 2009?
Provide a succinct answer. -5.95. What is the difference between the Exports(as % of merchandise exports) of Latin America(all income levels) in 2006 and the Exports(as % of merchandise exports) of Guatemala in 2009?
Your answer should be compact. 17.95. What is the difference between the Exports(as % of merchandise exports) in Sub-Saharan Africa (all income levels) in 2006 and the Exports(as % of merchandise exports) in Belize in 2009?
Provide a short and direct response. 17.03. What is the difference between the Exports(as % of merchandise exports) of Sub-Saharan Africa (all income levels) in 2006 and the Exports(as % of merchandise exports) of Guatemala in 2009?
Keep it short and to the point. 40.93. What is the difference between the Exports(as % of merchandise exports) in Belize in 2006 and the Exports(as % of merchandise exports) in Guatemala in 2009?
Make the answer very short. 12.48. What is the difference between the Exports(as % of merchandise exports) in Latin America(all income levels) in 2006 and the Exports(as % of merchandise exports) in Sub-Saharan Africa (all income levels) in 2010?
Ensure brevity in your answer.  -18.09. What is the difference between the Exports(as % of merchandise exports) of Latin America(all income levels) in 2006 and the Exports(as % of merchandise exports) of Belize in 2010?
Offer a very short reply. -14.13. What is the difference between the Exports(as % of merchandise exports) of Latin America(all income levels) in 2006 and the Exports(as % of merchandise exports) of Guatemala in 2010?
Your answer should be compact. 17.47. What is the difference between the Exports(as % of merchandise exports) of Sub-Saharan Africa (all income levels) in 2006 and the Exports(as % of merchandise exports) of Belize in 2010?
Offer a very short reply. 8.85. What is the difference between the Exports(as % of merchandise exports) in Sub-Saharan Africa (all income levels) in 2006 and the Exports(as % of merchandise exports) in Guatemala in 2010?
Your response must be concise. 40.45. What is the difference between the Exports(as % of merchandise exports) of Belize in 2006 and the Exports(as % of merchandise exports) of Guatemala in 2010?
Offer a very short reply. 12. What is the difference between the Exports(as % of merchandise exports) in Latin America(all income levels) in 2007 and the Exports(as % of merchandise exports) in Sub-Saharan Africa (all income levels) in 2008?
Give a very brief answer. -28.57. What is the difference between the Exports(as % of merchandise exports) in Latin America(all income levels) in 2007 and the Exports(as % of merchandise exports) in Belize in 2008?
Your response must be concise. -26.03. What is the difference between the Exports(as % of merchandise exports) in Latin America(all income levels) in 2007 and the Exports(as % of merchandise exports) in Guatemala in 2008?
Ensure brevity in your answer.  7.23. What is the difference between the Exports(as % of merchandise exports) in Sub-Saharan Africa (all income levels) in 2007 and the Exports(as % of merchandise exports) in Belize in 2008?
Offer a very short reply. 2.21. What is the difference between the Exports(as % of merchandise exports) of Sub-Saharan Africa (all income levels) in 2007 and the Exports(as % of merchandise exports) of Guatemala in 2008?
Your response must be concise. 35.47. What is the difference between the Exports(as % of merchandise exports) of Belize in 2007 and the Exports(as % of merchandise exports) of Guatemala in 2008?
Offer a terse response. 21.21. What is the difference between the Exports(as % of merchandise exports) of Latin America(all income levels) in 2007 and the Exports(as % of merchandise exports) of Sub-Saharan Africa (all income levels) in 2009?
Make the answer very short. -28.29. What is the difference between the Exports(as % of merchandise exports) in Latin America(all income levels) in 2007 and the Exports(as % of merchandise exports) in Belize in 2009?
Offer a terse response. -13.74. What is the difference between the Exports(as % of merchandise exports) in Latin America(all income levels) in 2007 and the Exports(as % of merchandise exports) in Guatemala in 2009?
Your answer should be compact. 10.16. What is the difference between the Exports(as % of merchandise exports) of Sub-Saharan Africa (all income levels) in 2007 and the Exports(as % of merchandise exports) of Belize in 2009?
Offer a very short reply. 14.5. What is the difference between the Exports(as % of merchandise exports) of Sub-Saharan Africa (all income levels) in 2007 and the Exports(as % of merchandise exports) of Guatemala in 2009?
Offer a terse response. 38.4. What is the difference between the Exports(as % of merchandise exports) in Belize in 2007 and the Exports(as % of merchandise exports) in Guatemala in 2009?
Your answer should be very brief. 24.14. What is the difference between the Exports(as % of merchandise exports) of Latin America(all income levels) in 2007 and the Exports(as % of merchandise exports) of Sub-Saharan Africa (all income levels) in 2010?
Offer a very short reply. -25.88. What is the difference between the Exports(as % of merchandise exports) in Latin America(all income levels) in 2007 and the Exports(as % of merchandise exports) in Belize in 2010?
Provide a short and direct response. -21.92. What is the difference between the Exports(as % of merchandise exports) in Latin America(all income levels) in 2007 and the Exports(as % of merchandise exports) in Guatemala in 2010?
Your answer should be compact. 9.69. What is the difference between the Exports(as % of merchandise exports) of Sub-Saharan Africa (all income levels) in 2007 and the Exports(as % of merchandise exports) of Belize in 2010?
Provide a succinct answer. 6.32. What is the difference between the Exports(as % of merchandise exports) of Sub-Saharan Africa (all income levels) in 2007 and the Exports(as % of merchandise exports) of Guatemala in 2010?
Ensure brevity in your answer.  37.93. What is the difference between the Exports(as % of merchandise exports) in Belize in 2007 and the Exports(as % of merchandise exports) in Guatemala in 2010?
Offer a terse response. 23.66. What is the difference between the Exports(as % of merchandise exports) of Latin America(all income levels) in 2008 and the Exports(as % of merchandise exports) of Sub-Saharan Africa (all income levels) in 2009?
Your answer should be compact. -19.08. What is the difference between the Exports(as % of merchandise exports) in Latin America(all income levels) in 2008 and the Exports(as % of merchandise exports) in Belize in 2009?
Your answer should be compact. -4.53. What is the difference between the Exports(as % of merchandise exports) in Latin America(all income levels) in 2008 and the Exports(as % of merchandise exports) in Guatemala in 2009?
Provide a succinct answer. 19.37. What is the difference between the Exports(as % of merchandise exports) of Sub-Saharan Africa (all income levels) in 2008 and the Exports(as % of merchandise exports) of Belize in 2009?
Offer a very short reply. 14.83. What is the difference between the Exports(as % of merchandise exports) of Sub-Saharan Africa (all income levels) in 2008 and the Exports(as % of merchandise exports) of Guatemala in 2009?
Your answer should be very brief. 38.74. What is the difference between the Exports(as % of merchandise exports) in Belize in 2008 and the Exports(as % of merchandise exports) in Guatemala in 2009?
Ensure brevity in your answer.  36.2. What is the difference between the Exports(as % of merchandise exports) of Latin America(all income levels) in 2008 and the Exports(as % of merchandise exports) of Sub-Saharan Africa (all income levels) in 2010?
Offer a very short reply. -16.67. What is the difference between the Exports(as % of merchandise exports) of Latin America(all income levels) in 2008 and the Exports(as % of merchandise exports) of Belize in 2010?
Make the answer very short. -12.71. What is the difference between the Exports(as % of merchandise exports) in Latin America(all income levels) in 2008 and the Exports(as % of merchandise exports) in Guatemala in 2010?
Your answer should be compact. 18.89. What is the difference between the Exports(as % of merchandise exports) in Sub-Saharan Africa (all income levels) in 2008 and the Exports(as % of merchandise exports) in Belize in 2010?
Your response must be concise. 6.65. What is the difference between the Exports(as % of merchandise exports) of Sub-Saharan Africa (all income levels) in 2008 and the Exports(as % of merchandise exports) of Guatemala in 2010?
Keep it short and to the point. 38.26. What is the difference between the Exports(as % of merchandise exports) in Belize in 2008 and the Exports(as % of merchandise exports) in Guatemala in 2010?
Your answer should be very brief. 35.72. What is the difference between the Exports(as % of merchandise exports) of Latin America(all income levels) in 2009 and the Exports(as % of merchandise exports) of Sub-Saharan Africa (all income levels) in 2010?
Offer a very short reply. -18.31. What is the difference between the Exports(as % of merchandise exports) of Latin America(all income levels) in 2009 and the Exports(as % of merchandise exports) of Belize in 2010?
Give a very brief answer. -14.36. What is the difference between the Exports(as % of merchandise exports) of Latin America(all income levels) in 2009 and the Exports(as % of merchandise exports) of Guatemala in 2010?
Give a very brief answer. 17.25. What is the difference between the Exports(as % of merchandise exports) in Sub-Saharan Africa (all income levels) in 2009 and the Exports(as % of merchandise exports) in Belize in 2010?
Give a very brief answer. 6.37. What is the difference between the Exports(as % of merchandise exports) of Sub-Saharan Africa (all income levels) in 2009 and the Exports(as % of merchandise exports) of Guatemala in 2010?
Offer a very short reply. 37.98. What is the difference between the Exports(as % of merchandise exports) in Belize in 2009 and the Exports(as % of merchandise exports) in Guatemala in 2010?
Keep it short and to the point. 23.43. What is the average Exports(as % of merchandise exports) of Latin America(all income levels) per year?
Your response must be concise. 20.04. What is the average Exports(as % of merchandise exports) in Sub-Saharan Africa (all income levels) per year?
Your answer should be very brief. 42.45. What is the average Exports(as % of merchandise exports) of Belize per year?
Your answer should be very brief. 24.61. What is the average Exports(as % of merchandise exports) in Guatemala per year?
Keep it short and to the point. 4.53. In the year 1978, what is the difference between the Exports(as % of merchandise exports) of Latin America(all income levels) and Exports(as % of merchandise exports) of Sub-Saharan Africa (all income levels)?
Your answer should be very brief. -17.23. In the year 1978, what is the difference between the Exports(as % of merchandise exports) in Latin America(all income levels) and Exports(as % of merchandise exports) in Belize?
Your response must be concise. 22.66. In the year 1978, what is the difference between the Exports(as % of merchandise exports) in Latin America(all income levels) and Exports(as % of merchandise exports) in Guatemala?
Your response must be concise. 24.75. In the year 1978, what is the difference between the Exports(as % of merchandise exports) of Sub-Saharan Africa (all income levels) and Exports(as % of merchandise exports) of Belize?
Give a very brief answer. 39.9. In the year 1978, what is the difference between the Exports(as % of merchandise exports) in Sub-Saharan Africa (all income levels) and Exports(as % of merchandise exports) in Guatemala?
Offer a very short reply. 41.98. In the year 1978, what is the difference between the Exports(as % of merchandise exports) of Belize and Exports(as % of merchandise exports) of Guatemala?
Provide a succinct answer. 2.09. In the year 1996, what is the difference between the Exports(as % of merchandise exports) in Latin America(all income levels) and Exports(as % of merchandise exports) in Sub-Saharan Africa (all income levels)?
Offer a very short reply. -25.38. In the year 1996, what is the difference between the Exports(as % of merchandise exports) in Latin America(all income levels) and Exports(as % of merchandise exports) in Belize?
Your answer should be compact. 16.72. In the year 1996, what is the difference between the Exports(as % of merchandise exports) of Latin America(all income levels) and Exports(as % of merchandise exports) of Guatemala?
Your response must be concise. 13.48. In the year 1996, what is the difference between the Exports(as % of merchandise exports) of Sub-Saharan Africa (all income levels) and Exports(as % of merchandise exports) of Belize?
Make the answer very short. 42.1. In the year 1996, what is the difference between the Exports(as % of merchandise exports) in Sub-Saharan Africa (all income levels) and Exports(as % of merchandise exports) in Guatemala?
Provide a short and direct response. 38.86. In the year 1996, what is the difference between the Exports(as % of merchandise exports) of Belize and Exports(as % of merchandise exports) of Guatemala?
Offer a terse response. -3.24. In the year 1999, what is the difference between the Exports(as % of merchandise exports) in Latin America(all income levels) and Exports(as % of merchandise exports) in Sub-Saharan Africa (all income levels)?
Keep it short and to the point. -27.47. In the year 1999, what is the difference between the Exports(as % of merchandise exports) in Latin America(all income levels) and Exports(as % of merchandise exports) in Belize?
Provide a succinct answer. -30.53. In the year 1999, what is the difference between the Exports(as % of merchandise exports) of Latin America(all income levels) and Exports(as % of merchandise exports) of Guatemala?
Provide a succinct answer. 11.58. In the year 1999, what is the difference between the Exports(as % of merchandise exports) of Sub-Saharan Africa (all income levels) and Exports(as % of merchandise exports) of Belize?
Offer a very short reply. -3.06. In the year 1999, what is the difference between the Exports(as % of merchandise exports) of Sub-Saharan Africa (all income levels) and Exports(as % of merchandise exports) of Guatemala?
Provide a succinct answer. 39.05. In the year 1999, what is the difference between the Exports(as % of merchandise exports) in Belize and Exports(as % of merchandise exports) in Guatemala?
Your response must be concise. 42.11. In the year 2006, what is the difference between the Exports(as % of merchandise exports) in Latin America(all income levels) and Exports(as % of merchandise exports) in Sub-Saharan Africa (all income levels)?
Make the answer very short. -22.98. In the year 2006, what is the difference between the Exports(as % of merchandise exports) of Latin America(all income levels) and Exports(as % of merchandise exports) of Belize?
Your response must be concise. 5.47. In the year 2006, what is the difference between the Exports(as % of merchandise exports) in Latin America(all income levels) and Exports(as % of merchandise exports) in Guatemala?
Ensure brevity in your answer.  13.21. In the year 2006, what is the difference between the Exports(as % of merchandise exports) in Sub-Saharan Africa (all income levels) and Exports(as % of merchandise exports) in Belize?
Your answer should be very brief. 28.45. In the year 2006, what is the difference between the Exports(as % of merchandise exports) in Sub-Saharan Africa (all income levels) and Exports(as % of merchandise exports) in Guatemala?
Provide a succinct answer. 36.19. In the year 2006, what is the difference between the Exports(as % of merchandise exports) of Belize and Exports(as % of merchandise exports) of Guatemala?
Your response must be concise. 7.74. In the year 2007, what is the difference between the Exports(as % of merchandise exports) in Latin America(all income levels) and Exports(as % of merchandise exports) in Sub-Saharan Africa (all income levels)?
Make the answer very short. -28.24. In the year 2007, what is the difference between the Exports(as % of merchandise exports) of Latin America(all income levels) and Exports(as % of merchandise exports) of Belize?
Ensure brevity in your answer.  -13.98. In the year 2007, what is the difference between the Exports(as % of merchandise exports) in Latin America(all income levels) and Exports(as % of merchandise exports) in Guatemala?
Your answer should be compact. 9.16. In the year 2007, what is the difference between the Exports(as % of merchandise exports) of Sub-Saharan Africa (all income levels) and Exports(as % of merchandise exports) of Belize?
Ensure brevity in your answer.  14.26. In the year 2007, what is the difference between the Exports(as % of merchandise exports) of Sub-Saharan Africa (all income levels) and Exports(as % of merchandise exports) of Guatemala?
Your answer should be very brief. 37.4. In the year 2007, what is the difference between the Exports(as % of merchandise exports) in Belize and Exports(as % of merchandise exports) in Guatemala?
Ensure brevity in your answer.  23.13. In the year 2008, what is the difference between the Exports(as % of merchandise exports) of Latin America(all income levels) and Exports(as % of merchandise exports) of Sub-Saharan Africa (all income levels)?
Keep it short and to the point. -19.37. In the year 2008, what is the difference between the Exports(as % of merchandise exports) in Latin America(all income levels) and Exports(as % of merchandise exports) in Belize?
Ensure brevity in your answer.  -16.82. In the year 2008, what is the difference between the Exports(as % of merchandise exports) in Latin America(all income levels) and Exports(as % of merchandise exports) in Guatemala?
Your response must be concise. 16.44. In the year 2008, what is the difference between the Exports(as % of merchandise exports) in Sub-Saharan Africa (all income levels) and Exports(as % of merchandise exports) in Belize?
Your answer should be compact. 2.54. In the year 2008, what is the difference between the Exports(as % of merchandise exports) in Sub-Saharan Africa (all income levels) and Exports(as % of merchandise exports) in Guatemala?
Ensure brevity in your answer.  35.81. In the year 2008, what is the difference between the Exports(as % of merchandise exports) in Belize and Exports(as % of merchandise exports) in Guatemala?
Your response must be concise. 33.27. In the year 2009, what is the difference between the Exports(as % of merchandise exports) of Latin America(all income levels) and Exports(as % of merchandise exports) of Sub-Saharan Africa (all income levels)?
Ensure brevity in your answer.  -20.73. In the year 2009, what is the difference between the Exports(as % of merchandise exports) in Latin America(all income levels) and Exports(as % of merchandise exports) in Belize?
Offer a very short reply. -6.18. In the year 2009, what is the difference between the Exports(as % of merchandise exports) in Latin America(all income levels) and Exports(as % of merchandise exports) in Guatemala?
Your response must be concise. 17.73. In the year 2009, what is the difference between the Exports(as % of merchandise exports) in Sub-Saharan Africa (all income levels) and Exports(as % of merchandise exports) in Belize?
Offer a very short reply. 14.55. In the year 2009, what is the difference between the Exports(as % of merchandise exports) of Sub-Saharan Africa (all income levels) and Exports(as % of merchandise exports) of Guatemala?
Give a very brief answer. 38.46. In the year 2009, what is the difference between the Exports(as % of merchandise exports) of Belize and Exports(as % of merchandise exports) of Guatemala?
Make the answer very short. 23.91. In the year 2010, what is the difference between the Exports(as % of merchandise exports) of Latin America(all income levels) and Exports(as % of merchandise exports) of Sub-Saharan Africa (all income levels)?
Your answer should be very brief. -17.86. In the year 2010, what is the difference between the Exports(as % of merchandise exports) in Latin America(all income levels) and Exports(as % of merchandise exports) in Belize?
Provide a short and direct response. -13.91. In the year 2010, what is the difference between the Exports(as % of merchandise exports) of Latin America(all income levels) and Exports(as % of merchandise exports) of Guatemala?
Provide a short and direct response. 17.7. In the year 2010, what is the difference between the Exports(as % of merchandise exports) in Sub-Saharan Africa (all income levels) and Exports(as % of merchandise exports) in Belize?
Offer a very short reply. 3.95. In the year 2010, what is the difference between the Exports(as % of merchandise exports) in Sub-Saharan Africa (all income levels) and Exports(as % of merchandise exports) in Guatemala?
Give a very brief answer. 35.56. In the year 2010, what is the difference between the Exports(as % of merchandise exports) in Belize and Exports(as % of merchandise exports) in Guatemala?
Give a very brief answer. 31.61. What is the ratio of the Exports(as % of merchandise exports) of Latin America(all income levels) in 1978 to that in 1996?
Your answer should be very brief. 1.48. What is the ratio of the Exports(as % of merchandise exports) in Sub-Saharan Africa (all income levels) in 1978 to that in 1996?
Ensure brevity in your answer.  1. What is the ratio of the Exports(as % of merchandise exports) of Belize in 1978 to that in 1996?
Make the answer very short. 6108.53. What is the ratio of the Exports(as % of merchandise exports) of Guatemala in 1978 to that in 1996?
Make the answer very short. 0.01. What is the ratio of the Exports(as % of merchandise exports) in Latin America(all income levels) in 1978 to that in 1999?
Offer a terse response. 1.64. What is the ratio of the Exports(as % of merchandise exports) in Sub-Saharan Africa (all income levels) in 1978 to that in 1999?
Your answer should be very brief. 0.99. What is the ratio of the Exports(as % of merchandise exports) of Belize in 1978 to that in 1999?
Your answer should be compact. 0.05. What is the ratio of the Exports(as % of merchandise exports) in Guatemala in 1978 to that in 1999?
Keep it short and to the point. 0.01. What is the ratio of the Exports(as % of merchandise exports) of Latin America(all income levels) in 1978 to that in 2006?
Give a very brief answer. 1.13. What is the ratio of the Exports(as % of merchandise exports) in Sub-Saharan Africa (all income levels) in 1978 to that in 2006?
Your answer should be very brief. 0.93. What is the ratio of the Exports(as % of merchandise exports) in Belize in 1978 to that in 2006?
Make the answer very short. 0.13. What is the ratio of the Exports(as % of merchandise exports) of Guatemala in 1978 to that in 2006?
Your response must be concise. 0. What is the ratio of the Exports(as % of merchandise exports) in Latin America(all income levels) in 1978 to that in 2007?
Keep it short and to the point. 1.74. What is the ratio of the Exports(as % of merchandise exports) of Sub-Saharan Africa (all income levels) in 1978 to that in 2007?
Keep it short and to the point. 0.99. What is the ratio of the Exports(as % of merchandise exports) of Belize in 1978 to that in 2007?
Provide a short and direct response. 0.07. What is the ratio of the Exports(as % of merchandise exports) in Guatemala in 1978 to that in 2007?
Ensure brevity in your answer.  0.01. What is the ratio of the Exports(as % of merchandise exports) in Latin America(all income levels) in 1978 to that in 2008?
Give a very brief answer. 1.06. What is the ratio of the Exports(as % of merchandise exports) in Sub-Saharan Africa (all income levels) in 1978 to that in 2008?
Your response must be concise. 0.98. What is the ratio of the Exports(as % of merchandise exports) in Belize in 1978 to that in 2008?
Your answer should be very brief. 0.05. What is the ratio of the Exports(as % of merchandise exports) of Guatemala in 1978 to that in 2008?
Your response must be concise. 0. What is the ratio of the Exports(as % of merchandise exports) of Latin America(all income levels) in 1978 to that in 2009?
Your answer should be very brief. 1.14. What is the ratio of the Exports(as % of merchandise exports) of Sub-Saharan Africa (all income levels) in 1978 to that in 2009?
Offer a terse response. 0.99. What is the ratio of the Exports(as % of merchandise exports) of Belize in 1978 to that in 2009?
Provide a succinct answer. 0.08. What is the ratio of the Exports(as % of merchandise exports) of Guatemala in 1978 to that in 2009?
Your answer should be compact. 0.01. What is the ratio of the Exports(as % of merchandise exports) of Latin America(all income levels) in 1978 to that in 2010?
Your response must be concise. 1.11. What is the ratio of the Exports(as % of merchandise exports) in Sub-Saharan Africa (all income levels) in 1978 to that in 2010?
Ensure brevity in your answer.  1.05. What is the ratio of the Exports(as % of merchandise exports) of Belize in 1978 to that in 2010?
Keep it short and to the point. 0.06. What is the ratio of the Exports(as % of merchandise exports) of Guatemala in 1978 to that in 2010?
Provide a short and direct response. 0.01. What is the ratio of the Exports(as % of merchandise exports) of Latin America(all income levels) in 1996 to that in 1999?
Offer a terse response. 1.11. What is the ratio of the Exports(as % of merchandise exports) of Sub-Saharan Africa (all income levels) in 1996 to that in 1999?
Give a very brief answer. 0.99. What is the ratio of the Exports(as % of merchandise exports) of Guatemala in 1996 to that in 1999?
Your answer should be compact. 0.92. What is the ratio of the Exports(as % of merchandise exports) in Latin America(all income levels) in 1996 to that in 2006?
Provide a short and direct response. 0.76. What is the ratio of the Exports(as % of merchandise exports) in Sub-Saharan Africa (all income levels) in 1996 to that in 2006?
Provide a short and direct response. 0.94. What is the ratio of the Exports(as % of merchandise exports) of Belize in 1996 to that in 2006?
Give a very brief answer. 0. What is the ratio of the Exports(as % of merchandise exports) of Guatemala in 1996 to that in 2006?
Your answer should be very brief. 0.37. What is the ratio of the Exports(as % of merchandise exports) of Latin America(all income levels) in 1996 to that in 2007?
Ensure brevity in your answer.  1.18. What is the ratio of the Exports(as % of merchandise exports) in Sub-Saharan Africa (all income levels) in 1996 to that in 2007?
Give a very brief answer. 0.99. What is the ratio of the Exports(as % of merchandise exports) of Belize in 1996 to that in 2007?
Offer a very short reply. 0. What is the ratio of the Exports(as % of merchandise exports) of Guatemala in 1996 to that in 2007?
Ensure brevity in your answer.  0.64. What is the ratio of the Exports(as % of merchandise exports) of Latin America(all income levels) in 1996 to that in 2008?
Provide a short and direct response. 0.71. What is the ratio of the Exports(as % of merchandise exports) of Sub-Saharan Africa (all income levels) in 1996 to that in 2008?
Ensure brevity in your answer.  0.98. What is the ratio of the Exports(as % of merchandise exports) of Guatemala in 1996 to that in 2008?
Make the answer very short. 0.46. What is the ratio of the Exports(as % of merchandise exports) of Latin America(all income levels) in 1996 to that in 2009?
Your answer should be very brief. 0.77. What is the ratio of the Exports(as % of merchandise exports) of Guatemala in 1996 to that in 2009?
Make the answer very short. 0.8. What is the ratio of the Exports(as % of merchandise exports) of Latin America(all income levels) in 1996 to that in 2010?
Offer a very short reply. 0.75. What is the ratio of the Exports(as % of merchandise exports) in Sub-Saharan Africa (all income levels) in 1996 to that in 2010?
Your answer should be compact. 1.05. What is the ratio of the Exports(as % of merchandise exports) in Guatemala in 1996 to that in 2010?
Provide a succinct answer. 0.71. What is the ratio of the Exports(as % of merchandise exports) of Latin America(all income levels) in 1999 to that in 2006?
Make the answer very short. 0.69. What is the ratio of the Exports(as % of merchandise exports) of Sub-Saharan Africa (all income levels) in 1999 to that in 2006?
Give a very brief answer. 0.95. What is the ratio of the Exports(as % of merchandise exports) of Belize in 1999 to that in 2006?
Ensure brevity in your answer.  2.76. What is the ratio of the Exports(as % of merchandise exports) of Guatemala in 1999 to that in 2006?
Offer a very short reply. 0.4. What is the ratio of the Exports(as % of merchandise exports) of Latin America(all income levels) in 1999 to that in 2007?
Your answer should be compact. 1.06. What is the ratio of the Exports(as % of merchandise exports) of Sub-Saharan Africa (all income levels) in 1999 to that in 2007?
Give a very brief answer. 1. What is the ratio of the Exports(as % of merchandise exports) in Belize in 1999 to that in 2007?
Offer a very short reply. 1.62. What is the ratio of the Exports(as % of merchandise exports) in Guatemala in 1999 to that in 2007?
Give a very brief answer. 0.69. What is the ratio of the Exports(as % of merchandise exports) of Latin America(all income levels) in 1999 to that in 2008?
Offer a very short reply. 0.64. What is the ratio of the Exports(as % of merchandise exports) of Belize in 1999 to that in 2008?
Give a very brief answer. 1.13. What is the ratio of the Exports(as % of merchandise exports) in Guatemala in 1999 to that in 2008?
Provide a short and direct response. 0.5. What is the ratio of the Exports(as % of merchandise exports) in Latin America(all income levels) in 1999 to that in 2009?
Offer a very short reply. 0.69. What is the ratio of the Exports(as % of merchandise exports) in Belize in 1999 to that in 2009?
Your response must be concise. 1.63. What is the ratio of the Exports(as % of merchandise exports) of Guatemala in 1999 to that in 2009?
Keep it short and to the point. 0.86. What is the ratio of the Exports(as % of merchandise exports) in Latin America(all income levels) in 1999 to that in 2010?
Your answer should be very brief. 0.68. What is the ratio of the Exports(as % of merchandise exports) of Sub-Saharan Africa (all income levels) in 1999 to that in 2010?
Ensure brevity in your answer.  1.06. What is the ratio of the Exports(as % of merchandise exports) in Belize in 1999 to that in 2010?
Your response must be concise. 1.26. What is the ratio of the Exports(as % of merchandise exports) in Guatemala in 1999 to that in 2010?
Your answer should be compact. 0.77. What is the ratio of the Exports(as % of merchandise exports) of Latin America(all income levels) in 2006 to that in 2007?
Your answer should be very brief. 1.55. What is the ratio of the Exports(as % of merchandise exports) in Sub-Saharan Africa (all income levels) in 2006 to that in 2007?
Provide a succinct answer. 1.06. What is the ratio of the Exports(as % of merchandise exports) of Belize in 2006 to that in 2007?
Offer a terse response. 0.59. What is the ratio of the Exports(as % of merchandise exports) of Guatemala in 2006 to that in 2007?
Make the answer very short. 1.74. What is the ratio of the Exports(as % of merchandise exports) of Latin America(all income levels) in 2006 to that in 2008?
Keep it short and to the point. 0.94. What is the ratio of the Exports(as % of merchandise exports) in Sub-Saharan Africa (all income levels) in 2006 to that in 2008?
Offer a terse response. 1.05. What is the ratio of the Exports(as % of merchandise exports) of Belize in 2006 to that in 2008?
Ensure brevity in your answer.  0.41. What is the ratio of the Exports(as % of merchandise exports) of Guatemala in 2006 to that in 2008?
Keep it short and to the point. 1.26. What is the ratio of the Exports(as % of merchandise exports) of Latin America(all income levels) in 2006 to that in 2009?
Provide a succinct answer. 1.01. What is the ratio of the Exports(as % of merchandise exports) of Sub-Saharan Africa (all income levels) in 2006 to that in 2009?
Ensure brevity in your answer.  1.06. What is the ratio of the Exports(as % of merchandise exports) in Belize in 2006 to that in 2009?
Provide a short and direct response. 0.59. What is the ratio of the Exports(as % of merchandise exports) in Guatemala in 2006 to that in 2009?
Your answer should be compact. 2.17. What is the ratio of the Exports(as % of merchandise exports) in Sub-Saharan Africa (all income levels) in 2006 to that in 2010?
Provide a short and direct response. 1.12. What is the ratio of the Exports(as % of merchandise exports) of Belize in 2006 to that in 2010?
Give a very brief answer. 0.46. What is the ratio of the Exports(as % of merchandise exports) in Guatemala in 2006 to that in 2010?
Ensure brevity in your answer.  1.94. What is the ratio of the Exports(as % of merchandise exports) in Latin America(all income levels) in 2007 to that in 2008?
Your response must be concise. 0.61. What is the ratio of the Exports(as % of merchandise exports) in Belize in 2007 to that in 2008?
Give a very brief answer. 0.7. What is the ratio of the Exports(as % of merchandise exports) in Guatemala in 2007 to that in 2008?
Provide a succinct answer. 0.73. What is the ratio of the Exports(as % of merchandise exports) of Latin America(all income levels) in 2007 to that in 2009?
Ensure brevity in your answer.  0.65. What is the ratio of the Exports(as % of merchandise exports) of Belize in 2007 to that in 2009?
Offer a terse response. 1.01. What is the ratio of the Exports(as % of merchandise exports) of Guatemala in 2007 to that in 2009?
Offer a very short reply. 1.25. What is the ratio of the Exports(as % of merchandise exports) of Latin America(all income levels) in 2007 to that in 2010?
Provide a succinct answer. 0.64. What is the ratio of the Exports(as % of merchandise exports) in Sub-Saharan Africa (all income levels) in 2007 to that in 2010?
Your answer should be very brief. 1.06. What is the ratio of the Exports(as % of merchandise exports) of Belize in 2007 to that in 2010?
Provide a short and direct response. 0.78. What is the ratio of the Exports(as % of merchandise exports) of Guatemala in 2007 to that in 2010?
Provide a short and direct response. 1.12. What is the ratio of the Exports(as % of merchandise exports) in Latin America(all income levels) in 2008 to that in 2009?
Your answer should be very brief. 1.08. What is the ratio of the Exports(as % of merchandise exports) in Sub-Saharan Africa (all income levels) in 2008 to that in 2009?
Offer a very short reply. 1.01. What is the ratio of the Exports(as % of merchandise exports) in Belize in 2008 to that in 2009?
Your answer should be very brief. 1.44. What is the ratio of the Exports(as % of merchandise exports) in Guatemala in 2008 to that in 2009?
Offer a terse response. 1.72. What is the ratio of the Exports(as % of merchandise exports) in Latin America(all income levels) in 2008 to that in 2010?
Your response must be concise. 1.05. What is the ratio of the Exports(as % of merchandise exports) in Sub-Saharan Africa (all income levels) in 2008 to that in 2010?
Offer a very short reply. 1.07. What is the ratio of the Exports(as % of merchandise exports) in Belize in 2008 to that in 2010?
Provide a succinct answer. 1.11. What is the ratio of the Exports(as % of merchandise exports) in Guatemala in 2008 to that in 2010?
Offer a terse response. 1.54. What is the ratio of the Exports(as % of merchandise exports) of Latin America(all income levels) in 2009 to that in 2010?
Make the answer very short. 0.98. What is the ratio of the Exports(as % of merchandise exports) of Sub-Saharan Africa (all income levels) in 2009 to that in 2010?
Your response must be concise. 1.06. What is the ratio of the Exports(as % of merchandise exports) of Belize in 2009 to that in 2010?
Give a very brief answer. 0.77. What is the ratio of the Exports(as % of merchandise exports) in Guatemala in 2009 to that in 2010?
Make the answer very short. 0.89. What is the difference between the highest and the second highest Exports(as % of merchandise exports) of Latin America(all income levels)?
Offer a very short reply. 1.34. What is the difference between the highest and the second highest Exports(as % of merchandise exports) of Sub-Saharan Africa (all income levels)?
Your answer should be very brief. 2.19. What is the difference between the highest and the second highest Exports(as % of merchandise exports) in Belize?
Offer a very short reply. 5.35. What is the difference between the highest and the second highest Exports(as % of merchandise exports) of Guatemala?
Provide a short and direct response. 1.81. What is the difference between the highest and the lowest Exports(as % of merchandise exports) of Latin America(all income levels)?
Ensure brevity in your answer.  10.55. What is the difference between the highest and the lowest Exports(as % of merchandise exports) of Sub-Saharan Africa (all income levels)?
Offer a very short reply. 4.89. What is the difference between the highest and the lowest Exports(as % of merchandise exports) in Belize?
Provide a succinct answer. 45.62. What is the difference between the highest and the lowest Exports(as % of merchandise exports) in Guatemala?
Offer a terse response. 8.78. 